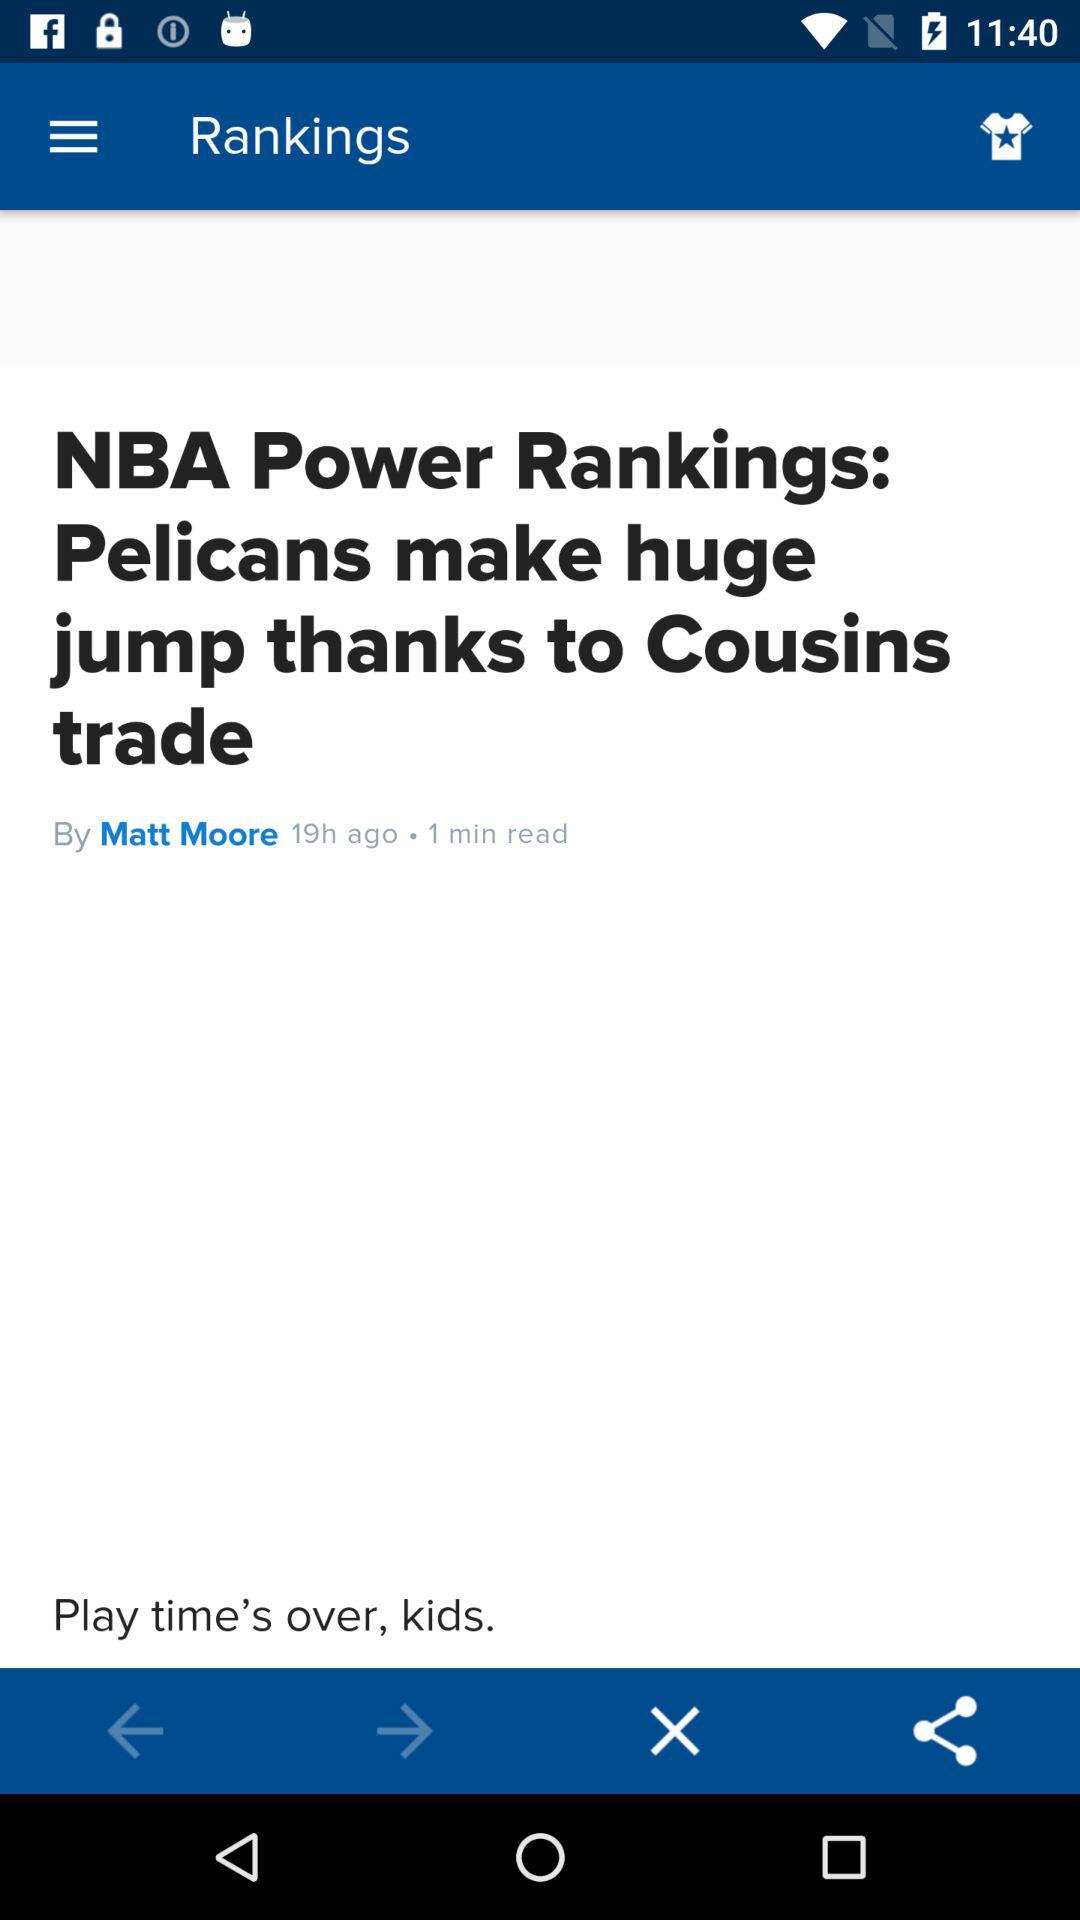How many hours ago was the article published?
Answer the question using a single word or phrase. 19 